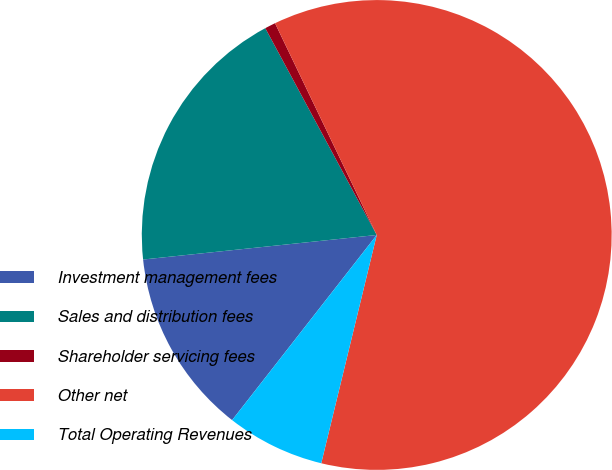Convert chart to OTSL. <chart><loc_0><loc_0><loc_500><loc_500><pie_chart><fcel>Investment management fees<fcel>Sales and distribution fees<fcel>Shareholder servicing fees<fcel>Other net<fcel>Total Operating Revenues<nl><fcel>12.78%<fcel>18.8%<fcel>0.74%<fcel>60.92%<fcel>6.76%<nl></chart> 